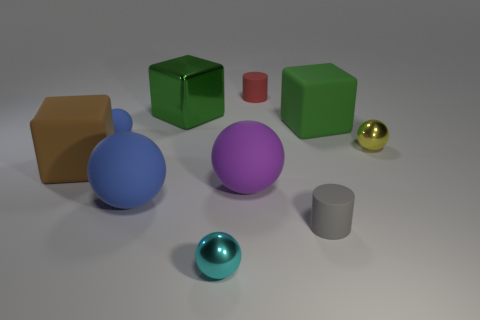What can you tell me about the composition and color scheme of the objects presented? The composition of the image is structured yet dynamic. The objects are arranged asymmetrically, giving the scene an organic feel. The color scheme is varied but balanced, with primary colors of red, blue, and yellow represented alongside secondary colors like purple and green. These are set against the neutral background and accented with the metallic gray of the steel or aluminum objects. This combination of colors and placement creates a visually pleasing array that also serves to differentiate each item clearly. 